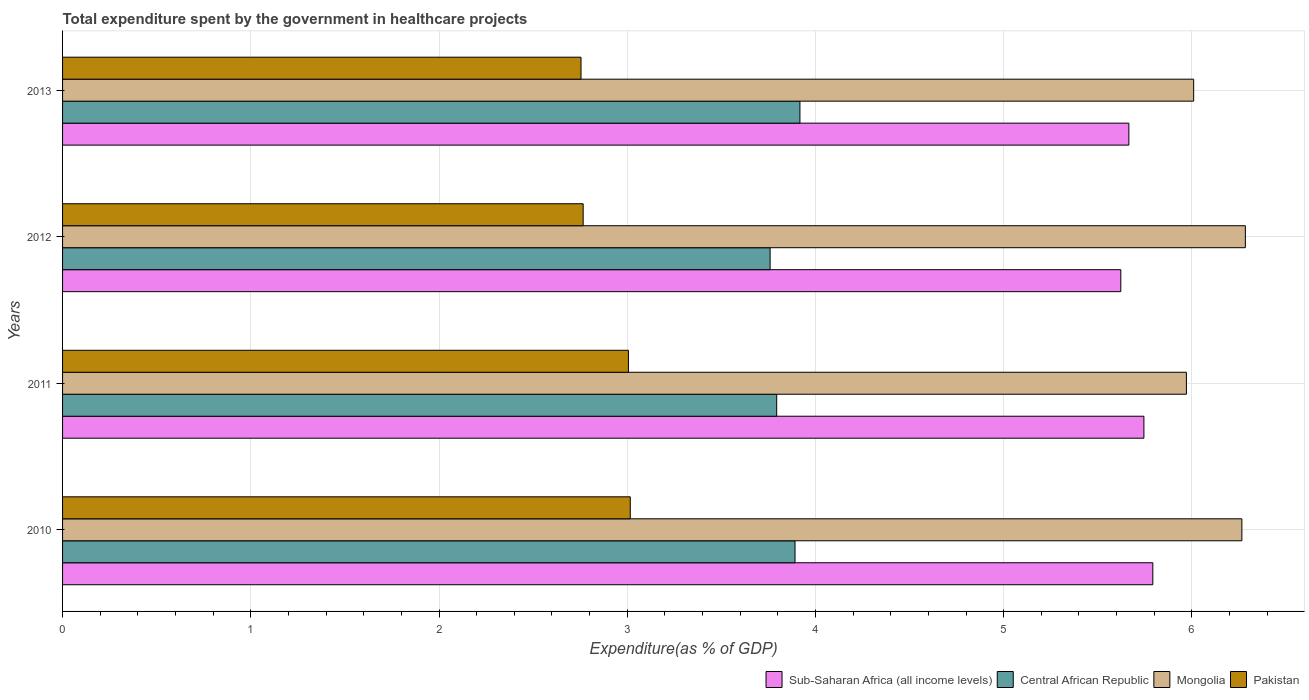How many groups of bars are there?
Ensure brevity in your answer.  4. Are the number of bars on each tick of the Y-axis equal?
Offer a very short reply. Yes. How many bars are there on the 4th tick from the bottom?
Your answer should be very brief. 4. What is the total expenditure spent by the government in healthcare projects in Central African Republic in 2010?
Your answer should be compact. 3.89. Across all years, what is the maximum total expenditure spent by the government in healthcare projects in Central African Republic?
Make the answer very short. 3.92. Across all years, what is the minimum total expenditure spent by the government in healthcare projects in Sub-Saharan Africa (all income levels)?
Provide a succinct answer. 5.62. What is the total total expenditure spent by the government in healthcare projects in Pakistan in the graph?
Offer a very short reply. 11.54. What is the difference between the total expenditure spent by the government in healthcare projects in Pakistan in 2010 and that in 2013?
Your response must be concise. 0.26. What is the difference between the total expenditure spent by the government in healthcare projects in Central African Republic in 2013 and the total expenditure spent by the government in healthcare projects in Sub-Saharan Africa (all income levels) in 2012?
Make the answer very short. -1.7. What is the average total expenditure spent by the government in healthcare projects in Sub-Saharan Africa (all income levels) per year?
Offer a terse response. 5.71. In the year 2013, what is the difference between the total expenditure spent by the government in healthcare projects in Pakistan and total expenditure spent by the government in healthcare projects in Sub-Saharan Africa (all income levels)?
Give a very brief answer. -2.91. In how many years, is the total expenditure spent by the government in healthcare projects in Mongolia greater than 0.6000000000000001 %?
Ensure brevity in your answer.  4. What is the ratio of the total expenditure spent by the government in healthcare projects in Mongolia in 2010 to that in 2011?
Offer a very short reply. 1.05. What is the difference between the highest and the second highest total expenditure spent by the government in healthcare projects in Pakistan?
Your answer should be very brief. 0.01. What is the difference between the highest and the lowest total expenditure spent by the government in healthcare projects in Sub-Saharan Africa (all income levels)?
Your answer should be very brief. 0.17. What does the 3rd bar from the top in 2010 represents?
Give a very brief answer. Central African Republic. What does the 2nd bar from the bottom in 2010 represents?
Make the answer very short. Central African Republic. Are the values on the major ticks of X-axis written in scientific E-notation?
Provide a succinct answer. No. Does the graph contain grids?
Ensure brevity in your answer.  Yes. Where does the legend appear in the graph?
Your answer should be compact. Bottom right. How are the legend labels stacked?
Give a very brief answer. Horizontal. What is the title of the graph?
Give a very brief answer. Total expenditure spent by the government in healthcare projects. Does "Croatia" appear as one of the legend labels in the graph?
Offer a very short reply. No. What is the label or title of the X-axis?
Give a very brief answer. Expenditure(as % of GDP). What is the label or title of the Y-axis?
Make the answer very short. Years. What is the Expenditure(as % of GDP) in Sub-Saharan Africa (all income levels) in 2010?
Offer a very short reply. 5.79. What is the Expenditure(as % of GDP) in Central African Republic in 2010?
Give a very brief answer. 3.89. What is the Expenditure(as % of GDP) of Mongolia in 2010?
Your answer should be compact. 6.27. What is the Expenditure(as % of GDP) in Pakistan in 2010?
Your answer should be very brief. 3.02. What is the Expenditure(as % of GDP) of Sub-Saharan Africa (all income levels) in 2011?
Offer a terse response. 5.74. What is the Expenditure(as % of GDP) in Central African Republic in 2011?
Offer a terse response. 3.79. What is the Expenditure(as % of GDP) of Mongolia in 2011?
Give a very brief answer. 5.97. What is the Expenditure(as % of GDP) of Pakistan in 2011?
Your response must be concise. 3.01. What is the Expenditure(as % of GDP) of Sub-Saharan Africa (all income levels) in 2012?
Your response must be concise. 5.62. What is the Expenditure(as % of GDP) of Central African Republic in 2012?
Give a very brief answer. 3.76. What is the Expenditure(as % of GDP) in Mongolia in 2012?
Your answer should be compact. 6.28. What is the Expenditure(as % of GDP) of Pakistan in 2012?
Your response must be concise. 2.77. What is the Expenditure(as % of GDP) in Sub-Saharan Africa (all income levels) in 2013?
Ensure brevity in your answer.  5.67. What is the Expenditure(as % of GDP) of Central African Republic in 2013?
Give a very brief answer. 3.92. What is the Expenditure(as % of GDP) in Mongolia in 2013?
Make the answer very short. 6.01. What is the Expenditure(as % of GDP) of Pakistan in 2013?
Offer a terse response. 2.75. Across all years, what is the maximum Expenditure(as % of GDP) of Sub-Saharan Africa (all income levels)?
Provide a succinct answer. 5.79. Across all years, what is the maximum Expenditure(as % of GDP) in Central African Republic?
Ensure brevity in your answer.  3.92. Across all years, what is the maximum Expenditure(as % of GDP) of Mongolia?
Make the answer very short. 6.28. Across all years, what is the maximum Expenditure(as % of GDP) of Pakistan?
Your answer should be compact. 3.02. Across all years, what is the minimum Expenditure(as % of GDP) of Sub-Saharan Africa (all income levels)?
Your answer should be compact. 5.62. Across all years, what is the minimum Expenditure(as % of GDP) of Central African Republic?
Offer a very short reply. 3.76. Across all years, what is the minimum Expenditure(as % of GDP) of Mongolia?
Ensure brevity in your answer.  5.97. Across all years, what is the minimum Expenditure(as % of GDP) in Pakistan?
Offer a very short reply. 2.75. What is the total Expenditure(as % of GDP) of Sub-Saharan Africa (all income levels) in the graph?
Provide a short and direct response. 22.82. What is the total Expenditure(as % of GDP) in Central African Republic in the graph?
Provide a short and direct response. 15.36. What is the total Expenditure(as % of GDP) in Mongolia in the graph?
Your answer should be compact. 24.53. What is the total Expenditure(as % of GDP) of Pakistan in the graph?
Offer a terse response. 11.54. What is the difference between the Expenditure(as % of GDP) in Sub-Saharan Africa (all income levels) in 2010 and that in 2011?
Provide a short and direct response. 0.05. What is the difference between the Expenditure(as % of GDP) in Central African Republic in 2010 and that in 2011?
Make the answer very short. 0.1. What is the difference between the Expenditure(as % of GDP) of Mongolia in 2010 and that in 2011?
Make the answer very short. 0.29. What is the difference between the Expenditure(as % of GDP) of Pakistan in 2010 and that in 2011?
Your response must be concise. 0.01. What is the difference between the Expenditure(as % of GDP) in Sub-Saharan Africa (all income levels) in 2010 and that in 2012?
Offer a very short reply. 0.17. What is the difference between the Expenditure(as % of GDP) of Central African Republic in 2010 and that in 2012?
Your answer should be very brief. 0.13. What is the difference between the Expenditure(as % of GDP) in Mongolia in 2010 and that in 2012?
Your answer should be compact. -0.02. What is the difference between the Expenditure(as % of GDP) in Pakistan in 2010 and that in 2012?
Ensure brevity in your answer.  0.25. What is the difference between the Expenditure(as % of GDP) of Sub-Saharan Africa (all income levels) in 2010 and that in 2013?
Provide a succinct answer. 0.13. What is the difference between the Expenditure(as % of GDP) in Central African Republic in 2010 and that in 2013?
Give a very brief answer. -0.03. What is the difference between the Expenditure(as % of GDP) in Mongolia in 2010 and that in 2013?
Your response must be concise. 0.26. What is the difference between the Expenditure(as % of GDP) in Pakistan in 2010 and that in 2013?
Your response must be concise. 0.26. What is the difference between the Expenditure(as % of GDP) in Sub-Saharan Africa (all income levels) in 2011 and that in 2012?
Provide a short and direct response. 0.12. What is the difference between the Expenditure(as % of GDP) of Central African Republic in 2011 and that in 2012?
Make the answer very short. 0.04. What is the difference between the Expenditure(as % of GDP) in Mongolia in 2011 and that in 2012?
Give a very brief answer. -0.31. What is the difference between the Expenditure(as % of GDP) in Pakistan in 2011 and that in 2012?
Keep it short and to the point. 0.24. What is the difference between the Expenditure(as % of GDP) of Sub-Saharan Africa (all income levels) in 2011 and that in 2013?
Make the answer very short. 0.08. What is the difference between the Expenditure(as % of GDP) in Central African Republic in 2011 and that in 2013?
Make the answer very short. -0.12. What is the difference between the Expenditure(as % of GDP) in Mongolia in 2011 and that in 2013?
Ensure brevity in your answer.  -0.04. What is the difference between the Expenditure(as % of GDP) in Pakistan in 2011 and that in 2013?
Offer a very short reply. 0.25. What is the difference between the Expenditure(as % of GDP) in Sub-Saharan Africa (all income levels) in 2012 and that in 2013?
Your answer should be compact. -0.04. What is the difference between the Expenditure(as % of GDP) in Central African Republic in 2012 and that in 2013?
Give a very brief answer. -0.16. What is the difference between the Expenditure(as % of GDP) in Mongolia in 2012 and that in 2013?
Ensure brevity in your answer.  0.27. What is the difference between the Expenditure(as % of GDP) of Pakistan in 2012 and that in 2013?
Keep it short and to the point. 0.01. What is the difference between the Expenditure(as % of GDP) of Sub-Saharan Africa (all income levels) in 2010 and the Expenditure(as % of GDP) of Central African Republic in 2011?
Offer a terse response. 2. What is the difference between the Expenditure(as % of GDP) in Sub-Saharan Africa (all income levels) in 2010 and the Expenditure(as % of GDP) in Mongolia in 2011?
Offer a terse response. -0.18. What is the difference between the Expenditure(as % of GDP) in Sub-Saharan Africa (all income levels) in 2010 and the Expenditure(as % of GDP) in Pakistan in 2011?
Make the answer very short. 2.79. What is the difference between the Expenditure(as % of GDP) of Central African Republic in 2010 and the Expenditure(as % of GDP) of Mongolia in 2011?
Make the answer very short. -2.08. What is the difference between the Expenditure(as % of GDP) in Central African Republic in 2010 and the Expenditure(as % of GDP) in Pakistan in 2011?
Provide a succinct answer. 0.89. What is the difference between the Expenditure(as % of GDP) of Mongolia in 2010 and the Expenditure(as % of GDP) of Pakistan in 2011?
Keep it short and to the point. 3.26. What is the difference between the Expenditure(as % of GDP) of Sub-Saharan Africa (all income levels) in 2010 and the Expenditure(as % of GDP) of Central African Republic in 2012?
Your answer should be very brief. 2.03. What is the difference between the Expenditure(as % of GDP) of Sub-Saharan Africa (all income levels) in 2010 and the Expenditure(as % of GDP) of Mongolia in 2012?
Provide a succinct answer. -0.49. What is the difference between the Expenditure(as % of GDP) of Sub-Saharan Africa (all income levels) in 2010 and the Expenditure(as % of GDP) of Pakistan in 2012?
Your answer should be very brief. 3.03. What is the difference between the Expenditure(as % of GDP) in Central African Republic in 2010 and the Expenditure(as % of GDP) in Mongolia in 2012?
Keep it short and to the point. -2.39. What is the difference between the Expenditure(as % of GDP) of Central African Republic in 2010 and the Expenditure(as % of GDP) of Pakistan in 2012?
Offer a terse response. 1.13. What is the difference between the Expenditure(as % of GDP) of Mongolia in 2010 and the Expenditure(as % of GDP) of Pakistan in 2012?
Give a very brief answer. 3.5. What is the difference between the Expenditure(as % of GDP) in Sub-Saharan Africa (all income levels) in 2010 and the Expenditure(as % of GDP) in Central African Republic in 2013?
Offer a terse response. 1.87. What is the difference between the Expenditure(as % of GDP) in Sub-Saharan Africa (all income levels) in 2010 and the Expenditure(as % of GDP) in Mongolia in 2013?
Your answer should be compact. -0.22. What is the difference between the Expenditure(as % of GDP) in Sub-Saharan Africa (all income levels) in 2010 and the Expenditure(as % of GDP) in Pakistan in 2013?
Make the answer very short. 3.04. What is the difference between the Expenditure(as % of GDP) in Central African Republic in 2010 and the Expenditure(as % of GDP) in Mongolia in 2013?
Offer a very short reply. -2.12. What is the difference between the Expenditure(as % of GDP) of Central African Republic in 2010 and the Expenditure(as % of GDP) of Pakistan in 2013?
Your answer should be very brief. 1.14. What is the difference between the Expenditure(as % of GDP) in Mongolia in 2010 and the Expenditure(as % of GDP) in Pakistan in 2013?
Offer a very short reply. 3.51. What is the difference between the Expenditure(as % of GDP) of Sub-Saharan Africa (all income levels) in 2011 and the Expenditure(as % of GDP) of Central African Republic in 2012?
Give a very brief answer. 1.99. What is the difference between the Expenditure(as % of GDP) in Sub-Saharan Africa (all income levels) in 2011 and the Expenditure(as % of GDP) in Mongolia in 2012?
Your answer should be very brief. -0.54. What is the difference between the Expenditure(as % of GDP) of Sub-Saharan Africa (all income levels) in 2011 and the Expenditure(as % of GDP) of Pakistan in 2012?
Provide a short and direct response. 2.98. What is the difference between the Expenditure(as % of GDP) of Central African Republic in 2011 and the Expenditure(as % of GDP) of Mongolia in 2012?
Ensure brevity in your answer.  -2.49. What is the difference between the Expenditure(as % of GDP) of Central African Republic in 2011 and the Expenditure(as % of GDP) of Pakistan in 2012?
Provide a short and direct response. 1.03. What is the difference between the Expenditure(as % of GDP) of Mongolia in 2011 and the Expenditure(as % of GDP) of Pakistan in 2012?
Give a very brief answer. 3.2. What is the difference between the Expenditure(as % of GDP) of Sub-Saharan Africa (all income levels) in 2011 and the Expenditure(as % of GDP) of Central African Republic in 2013?
Make the answer very short. 1.83. What is the difference between the Expenditure(as % of GDP) of Sub-Saharan Africa (all income levels) in 2011 and the Expenditure(as % of GDP) of Mongolia in 2013?
Your answer should be compact. -0.26. What is the difference between the Expenditure(as % of GDP) of Sub-Saharan Africa (all income levels) in 2011 and the Expenditure(as % of GDP) of Pakistan in 2013?
Provide a succinct answer. 2.99. What is the difference between the Expenditure(as % of GDP) of Central African Republic in 2011 and the Expenditure(as % of GDP) of Mongolia in 2013?
Keep it short and to the point. -2.22. What is the difference between the Expenditure(as % of GDP) in Central African Republic in 2011 and the Expenditure(as % of GDP) in Pakistan in 2013?
Keep it short and to the point. 1.04. What is the difference between the Expenditure(as % of GDP) in Mongolia in 2011 and the Expenditure(as % of GDP) in Pakistan in 2013?
Your answer should be compact. 3.22. What is the difference between the Expenditure(as % of GDP) of Sub-Saharan Africa (all income levels) in 2012 and the Expenditure(as % of GDP) of Central African Republic in 2013?
Your response must be concise. 1.7. What is the difference between the Expenditure(as % of GDP) in Sub-Saharan Africa (all income levels) in 2012 and the Expenditure(as % of GDP) in Mongolia in 2013?
Make the answer very short. -0.39. What is the difference between the Expenditure(as % of GDP) of Sub-Saharan Africa (all income levels) in 2012 and the Expenditure(as % of GDP) of Pakistan in 2013?
Offer a very short reply. 2.87. What is the difference between the Expenditure(as % of GDP) in Central African Republic in 2012 and the Expenditure(as % of GDP) in Mongolia in 2013?
Keep it short and to the point. -2.25. What is the difference between the Expenditure(as % of GDP) in Central African Republic in 2012 and the Expenditure(as % of GDP) in Pakistan in 2013?
Offer a very short reply. 1. What is the difference between the Expenditure(as % of GDP) of Mongolia in 2012 and the Expenditure(as % of GDP) of Pakistan in 2013?
Provide a succinct answer. 3.53. What is the average Expenditure(as % of GDP) of Sub-Saharan Africa (all income levels) per year?
Your answer should be compact. 5.71. What is the average Expenditure(as % of GDP) of Central African Republic per year?
Make the answer very short. 3.84. What is the average Expenditure(as % of GDP) of Mongolia per year?
Provide a succinct answer. 6.13. What is the average Expenditure(as % of GDP) of Pakistan per year?
Give a very brief answer. 2.89. In the year 2010, what is the difference between the Expenditure(as % of GDP) of Sub-Saharan Africa (all income levels) and Expenditure(as % of GDP) of Central African Republic?
Make the answer very short. 1.9. In the year 2010, what is the difference between the Expenditure(as % of GDP) in Sub-Saharan Africa (all income levels) and Expenditure(as % of GDP) in Mongolia?
Provide a short and direct response. -0.47. In the year 2010, what is the difference between the Expenditure(as % of GDP) in Sub-Saharan Africa (all income levels) and Expenditure(as % of GDP) in Pakistan?
Keep it short and to the point. 2.78. In the year 2010, what is the difference between the Expenditure(as % of GDP) of Central African Republic and Expenditure(as % of GDP) of Mongolia?
Make the answer very short. -2.37. In the year 2010, what is the difference between the Expenditure(as % of GDP) of Central African Republic and Expenditure(as % of GDP) of Pakistan?
Offer a very short reply. 0.88. In the year 2010, what is the difference between the Expenditure(as % of GDP) of Mongolia and Expenditure(as % of GDP) of Pakistan?
Keep it short and to the point. 3.25. In the year 2011, what is the difference between the Expenditure(as % of GDP) of Sub-Saharan Africa (all income levels) and Expenditure(as % of GDP) of Central African Republic?
Your answer should be very brief. 1.95. In the year 2011, what is the difference between the Expenditure(as % of GDP) of Sub-Saharan Africa (all income levels) and Expenditure(as % of GDP) of Mongolia?
Offer a terse response. -0.23. In the year 2011, what is the difference between the Expenditure(as % of GDP) of Sub-Saharan Africa (all income levels) and Expenditure(as % of GDP) of Pakistan?
Offer a terse response. 2.74. In the year 2011, what is the difference between the Expenditure(as % of GDP) in Central African Republic and Expenditure(as % of GDP) in Mongolia?
Provide a succinct answer. -2.18. In the year 2011, what is the difference between the Expenditure(as % of GDP) of Central African Republic and Expenditure(as % of GDP) of Pakistan?
Offer a terse response. 0.79. In the year 2011, what is the difference between the Expenditure(as % of GDP) of Mongolia and Expenditure(as % of GDP) of Pakistan?
Your answer should be compact. 2.96. In the year 2012, what is the difference between the Expenditure(as % of GDP) in Sub-Saharan Africa (all income levels) and Expenditure(as % of GDP) in Central African Republic?
Your answer should be compact. 1.86. In the year 2012, what is the difference between the Expenditure(as % of GDP) of Sub-Saharan Africa (all income levels) and Expenditure(as % of GDP) of Mongolia?
Provide a succinct answer. -0.66. In the year 2012, what is the difference between the Expenditure(as % of GDP) of Sub-Saharan Africa (all income levels) and Expenditure(as % of GDP) of Pakistan?
Ensure brevity in your answer.  2.86. In the year 2012, what is the difference between the Expenditure(as % of GDP) of Central African Republic and Expenditure(as % of GDP) of Mongolia?
Your response must be concise. -2.52. In the year 2012, what is the difference between the Expenditure(as % of GDP) in Mongolia and Expenditure(as % of GDP) in Pakistan?
Keep it short and to the point. 3.52. In the year 2013, what is the difference between the Expenditure(as % of GDP) in Sub-Saharan Africa (all income levels) and Expenditure(as % of GDP) in Central African Republic?
Offer a very short reply. 1.75. In the year 2013, what is the difference between the Expenditure(as % of GDP) of Sub-Saharan Africa (all income levels) and Expenditure(as % of GDP) of Mongolia?
Your answer should be compact. -0.34. In the year 2013, what is the difference between the Expenditure(as % of GDP) of Sub-Saharan Africa (all income levels) and Expenditure(as % of GDP) of Pakistan?
Make the answer very short. 2.91. In the year 2013, what is the difference between the Expenditure(as % of GDP) of Central African Republic and Expenditure(as % of GDP) of Mongolia?
Provide a short and direct response. -2.09. In the year 2013, what is the difference between the Expenditure(as % of GDP) in Central African Republic and Expenditure(as % of GDP) in Pakistan?
Keep it short and to the point. 1.16. In the year 2013, what is the difference between the Expenditure(as % of GDP) of Mongolia and Expenditure(as % of GDP) of Pakistan?
Your answer should be very brief. 3.25. What is the ratio of the Expenditure(as % of GDP) of Sub-Saharan Africa (all income levels) in 2010 to that in 2011?
Offer a terse response. 1.01. What is the ratio of the Expenditure(as % of GDP) in Central African Republic in 2010 to that in 2011?
Offer a very short reply. 1.03. What is the ratio of the Expenditure(as % of GDP) in Mongolia in 2010 to that in 2011?
Give a very brief answer. 1.05. What is the ratio of the Expenditure(as % of GDP) in Sub-Saharan Africa (all income levels) in 2010 to that in 2012?
Your response must be concise. 1.03. What is the ratio of the Expenditure(as % of GDP) of Central African Republic in 2010 to that in 2012?
Your answer should be compact. 1.04. What is the ratio of the Expenditure(as % of GDP) of Mongolia in 2010 to that in 2012?
Give a very brief answer. 1. What is the ratio of the Expenditure(as % of GDP) in Pakistan in 2010 to that in 2012?
Your answer should be compact. 1.09. What is the ratio of the Expenditure(as % of GDP) of Sub-Saharan Africa (all income levels) in 2010 to that in 2013?
Offer a terse response. 1.02. What is the ratio of the Expenditure(as % of GDP) of Mongolia in 2010 to that in 2013?
Provide a succinct answer. 1.04. What is the ratio of the Expenditure(as % of GDP) of Pakistan in 2010 to that in 2013?
Offer a terse response. 1.09. What is the ratio of the Expenditure(as % of GDP) in Sub-Saharan Africa (all income levels) in 2011 to that in 2012?
Offer a terse response. 1.02. What is the ratio of the Expenditure(as % of GDP) of Central African Republic in 2011 to that in 2012?
Offer a very short reply. 1.01. What is the ratio of the Expenditure(as % of GDP) of Mongolia in 2011 to that in 2012?
Keep it short and to the point. 0.95. What is the ratio of the Expenditure(as % of GDP) in Pakistan in 2011 to that in 2012?
Make the answer very short. 1.09. What is the ratio of the Expenditure(as % of GDP) in Sub-Saharan Africa (all income levels) in 2011 to that in 2013?
Make the answer very short. 1.01. What is the ratio of the Expenditure(as % of GDP) in Central African Republic in 2011 to that in 2013?
Ensure brevity in your answer.  0.97. What is the ratio of the Expenditure(as % of GDP) of Mongolia in 2011 to that in 2013?
Provide a succinct answer. 0.99. What is the ratio of the Expenditure(as % of GDP) in Pakistan in 2011 to that in 2013?
Your answer should be compact. 1.09. What is the ratio of the Expenditure(as % of GDP) in Central African Republic in 2012 to that in 2013?
Ensure brevity in your answer.  0.96. What is the ratio of the Expenditure(as % of GDP) of Mongolia in 2012 to that in 2013?
Your answer should be very brief. 1.05. What is the difference between the highest and the second highest Expenditure(as % of GDP) of Sub-Saharan Africa (all income levels)?
Provide a succinct answer. 0.05. What is the difference between the highest and the second highest Expenditure(as % of GDP) of Central African Republic?
Your answer should be compact. 0.03. What is the difference between the highest and the second highest Expenditure(as % of GDP) of Mongolia?
Offer a terse response. 0.02. What is the difference between the highest and the second highest Expenditure(as % of GDP) in Pakistan?
Ensure brevity in your answer.  0.01. What is the difference between the highest and the lowest Expenditure(as % of GDP) of Sub-Saharan Africa (all income levels)?
Keep it short and to the point. 0.17. What is the difference between the highest and the lowest Expenditure(as % of GDP) of Central African Republic?
Give a very brief answer. 0.16. What is the difference between the highest and the lowest Expenditure(as % of GDP) in Mongolia?
Provide a short and direct response. 0.31. What is the difference between the highest and the lowest Expenditure(as % of GDP) of Pakistan?
Make the answer very short. 0.26. 